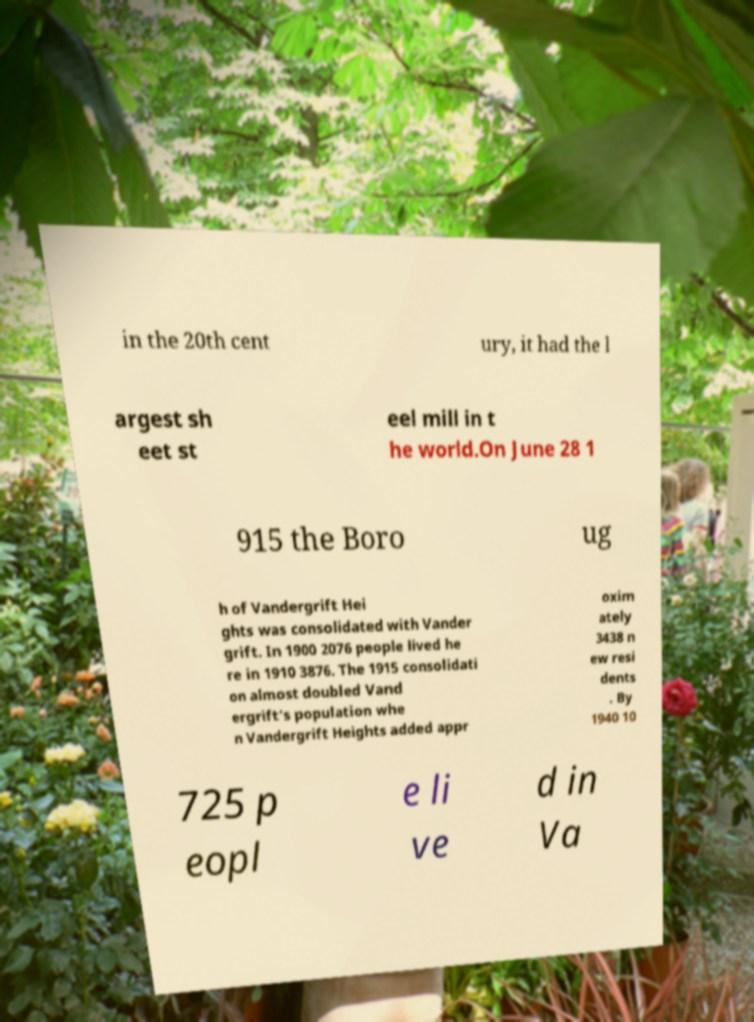For documentation purposes, I need the text within this image transcribed. Could you provide that? in the 20th cent ury, it had the l argest sh eet st eel mill in t he world.On June 28 1 915 the Boro ug h of Vandergrift Hei ghts was consolidated with Vander grift. In 1900 2076 people lived he re in 1910 3876. The 1915 consolidati on almost doubled Vand ergrift's population whe n Vandergrift Heights added appr oxim ately 3438 n ew resi dents . By 1940 10 725 p eopl e li ve d in Va 